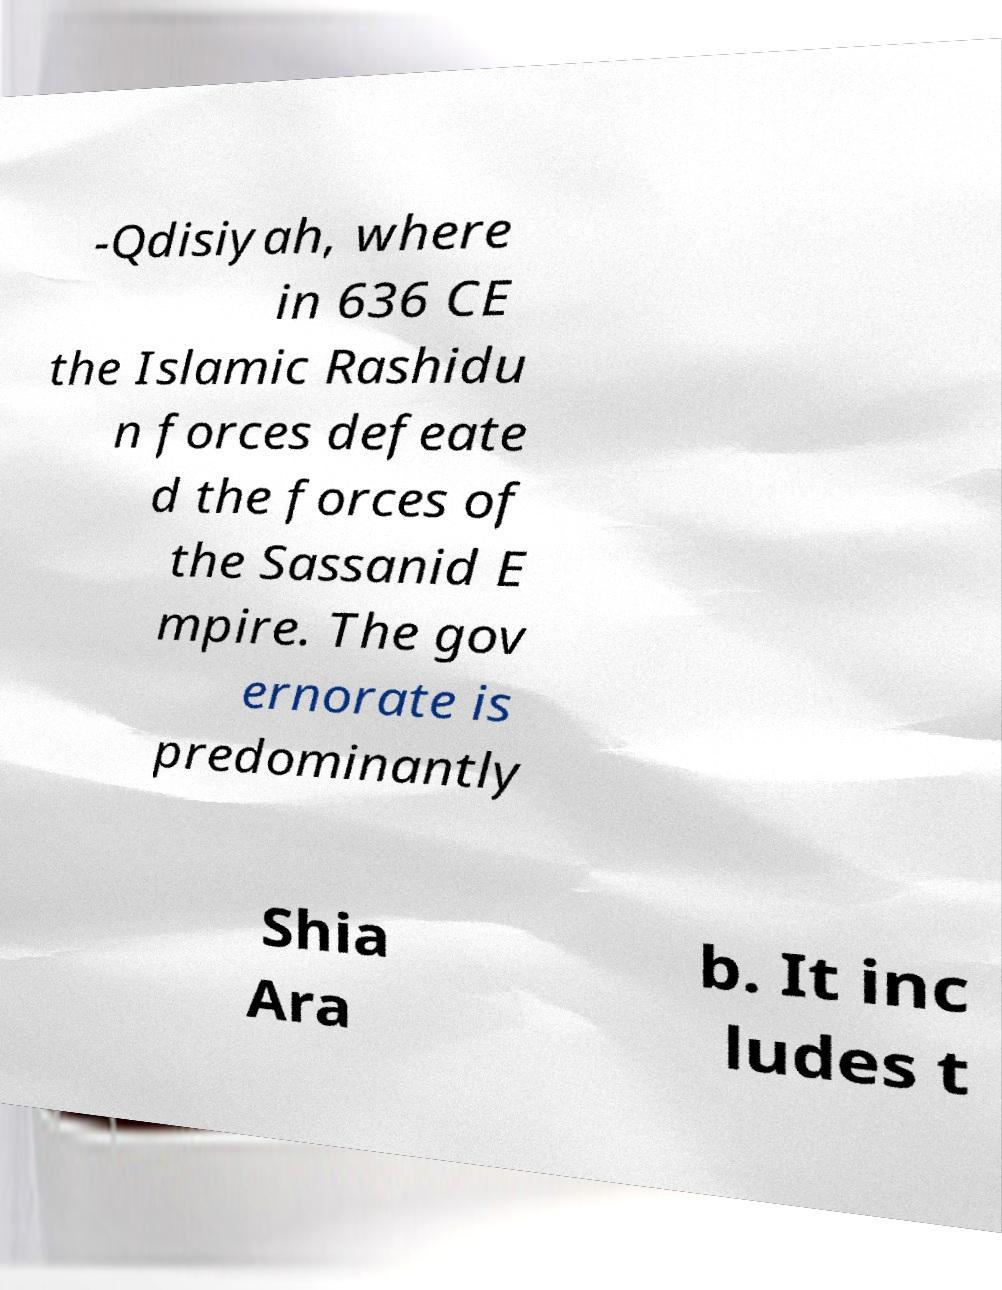Can you read and provide the text displayed in the image?This photo seems to have some interesting text. Can you extract and type it out for me? -Qdisiyah, where in 636 CE the Islamic Rashidu n forces defeate d the forces of the Sassanid E mpire. The gov ernorate is predominantly Shia Ara b. It inc ludes t 